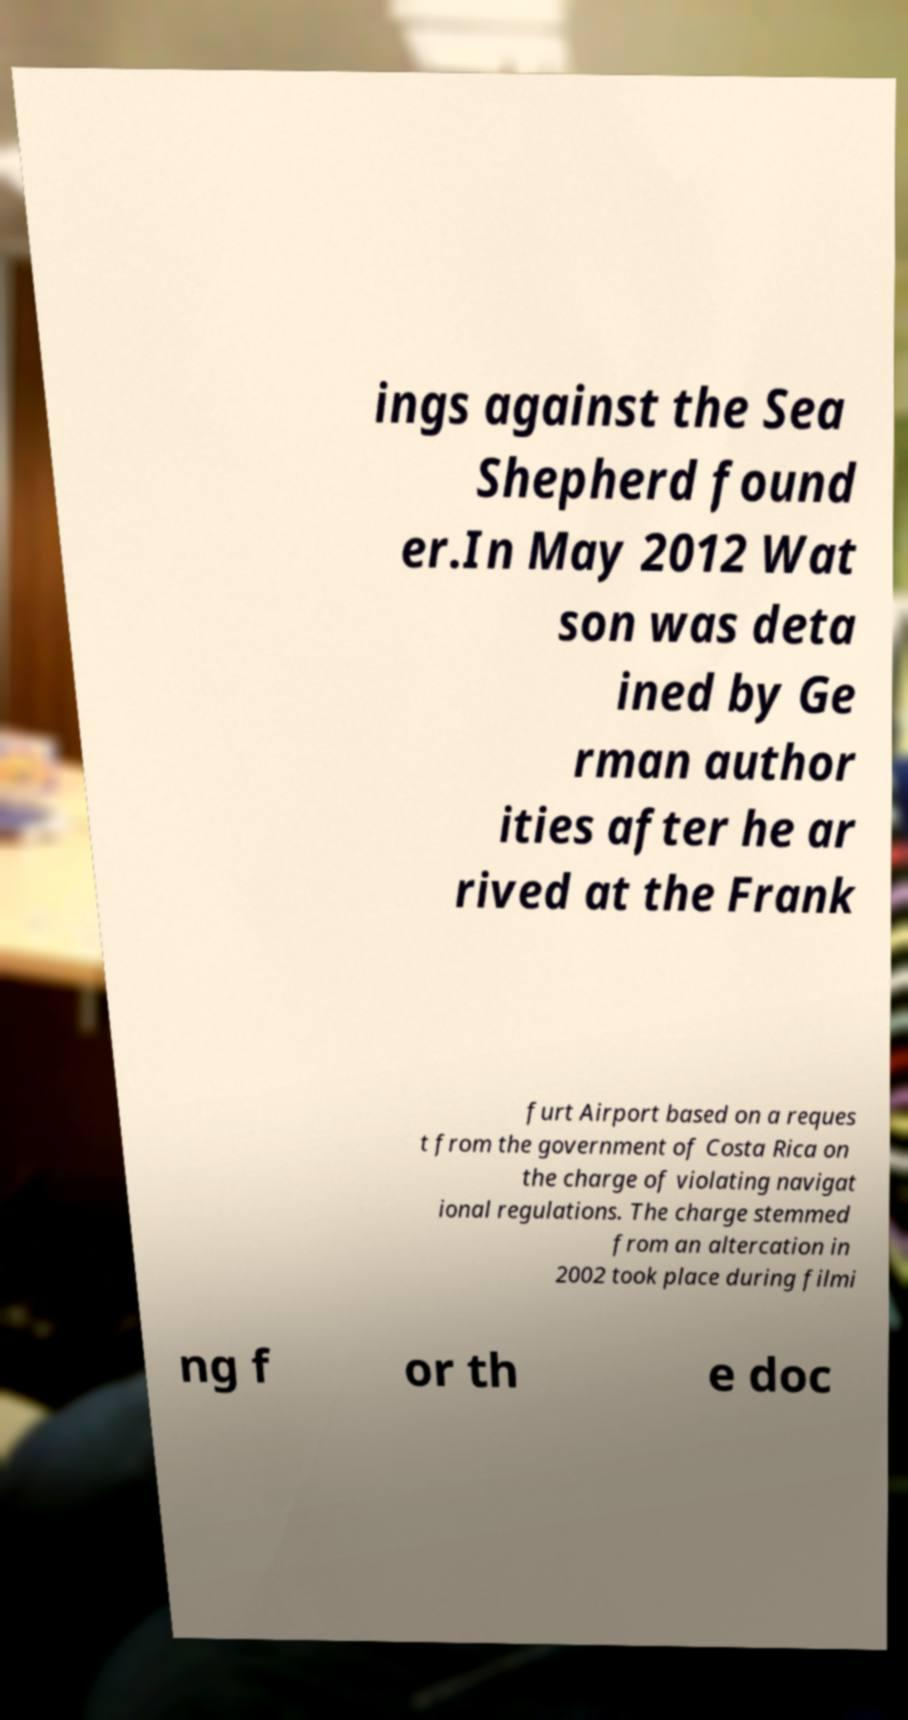Please identify and transcribe the text found in this image. ings against the Sea Shepherd found er.In May 2012 Wat son was deta ined by Ge rman author ities after he ar rived at the Frank furt Airport based on a reques t from the government of Costa Rica on the charge of violating navigat ional regulations. The charge stemmed from an altercation in 2002 took place during filmi ng f or th e doc 